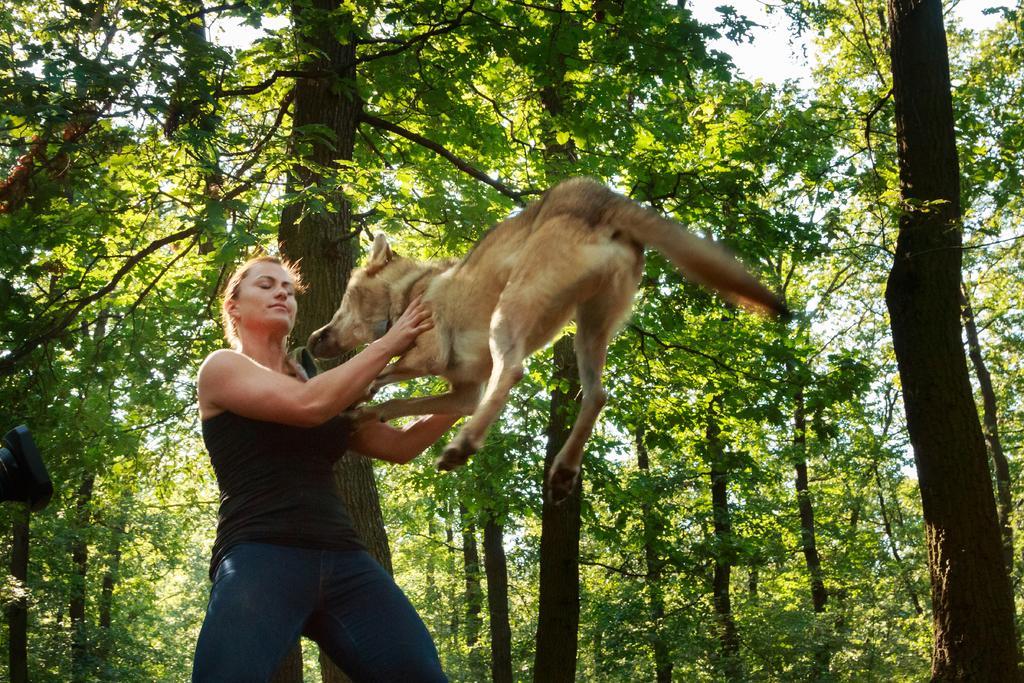Can you describe this image briefly? this picture is taken in the forest, in the left side there is a woman she is standing and holding a dog which is in yellow color, in the background there are some green color trees and there is a sky in white color. 